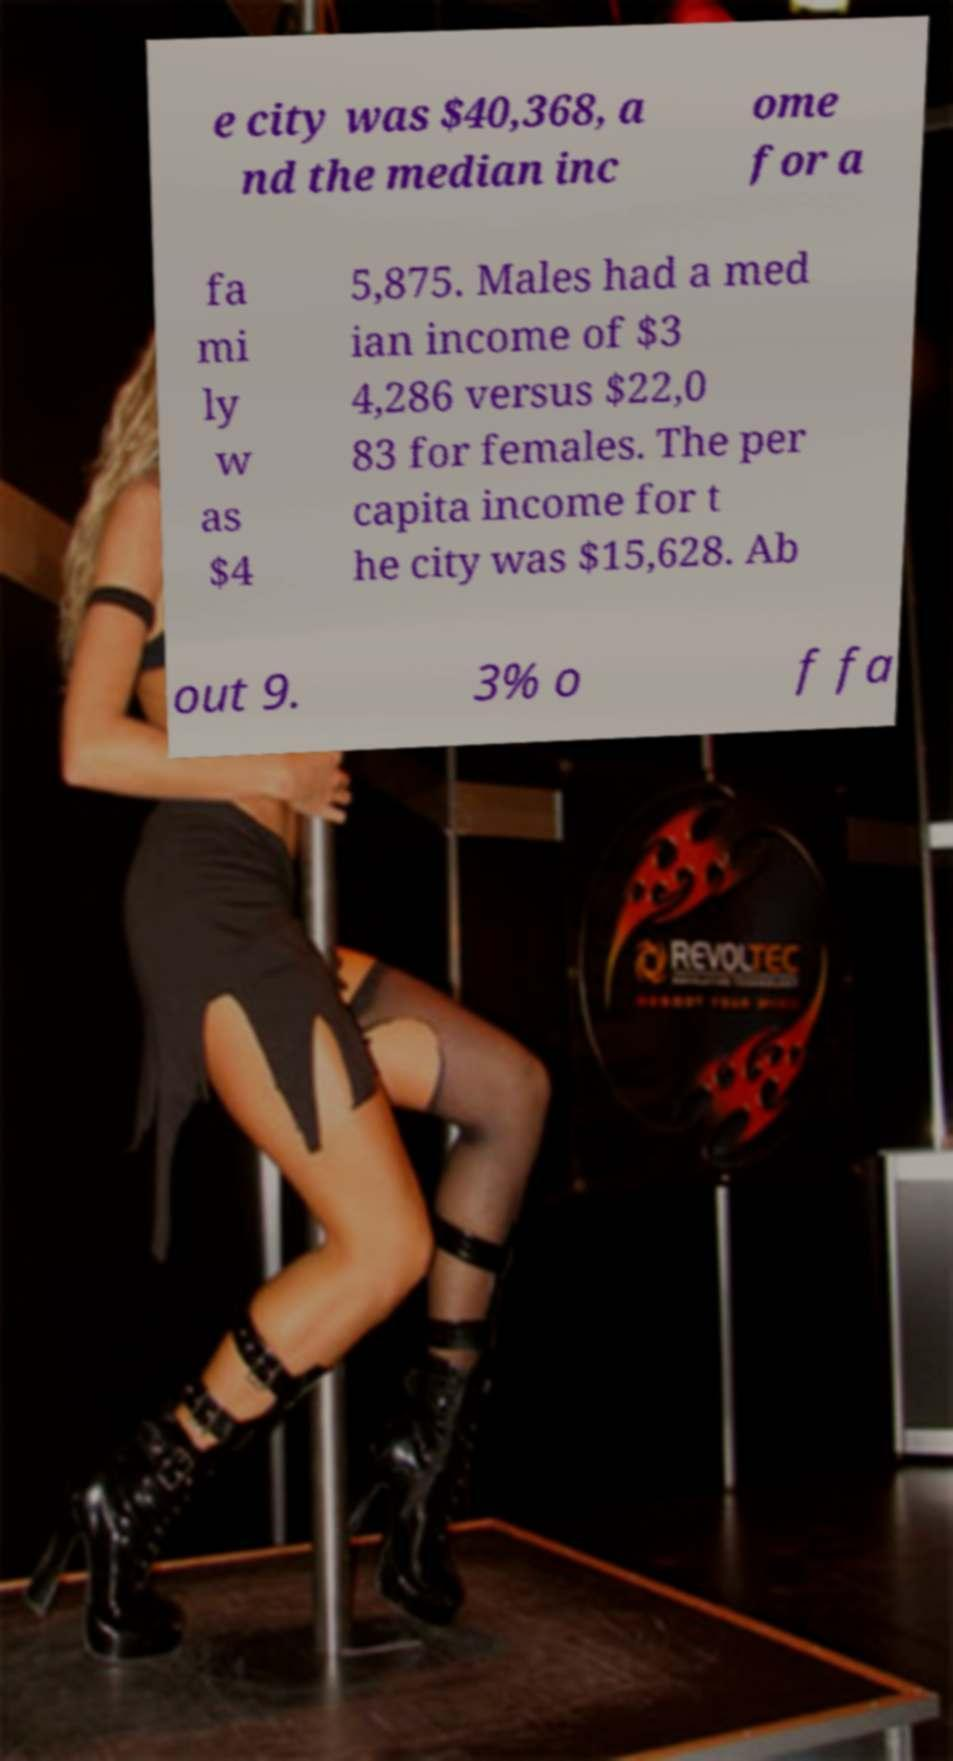Can you read and provide the text displayed in the image?This photo seems to have some interesting text. Can you extract and type it out for me? e city was $40,368, a nd the median inc ome for a fa mi ly w as $4 5,875. Males had a med ian income of $3 4,286 versus $22,0 83 for females. The per capita income for t he city was $15,628. Ab out 9. 3% o f fa 